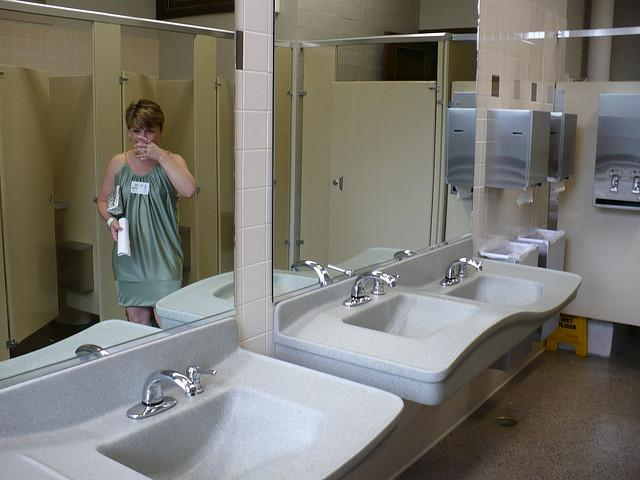What is the woman wearing? Please explain your reasoning. dress. She's wearing a top that's almost knee length. 